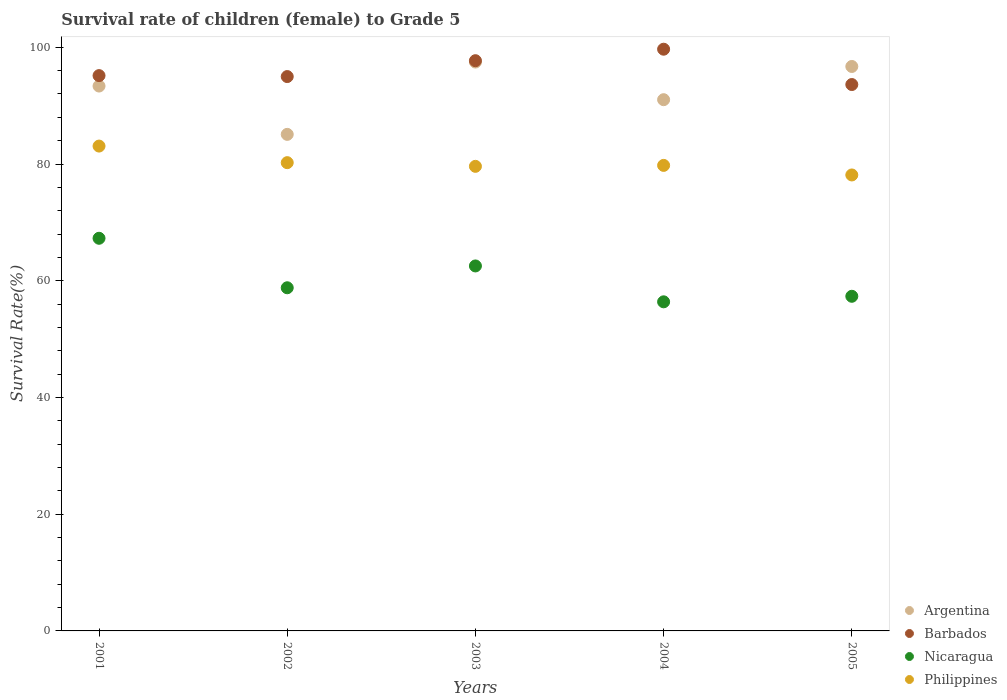How many different coloured dotlines are there?
Your answer should be compact. 4. Is the number of dotlines equal to the number of legend labels?
Keep it short and to the point. Yes. What is the survival rate of female children to grade 5 in Philippines in 2001?
Provide a succinct answer. 83.08. Across all years, what is the maximum survival rate of female children to grade 5 in Philippines?
Offer a very short reply. 83.08. Across all years, what is the minimum survival rate of female children to grade 5 in Philippines?
Provide a short and direct response. 78.13. In which year was the survival rate of female children to grade 5 in Nicaragua maximum?
Ensure brevity in your answer.  2001. In which year was the survival rate of female children to grade 5 in Barbados minimum?
Your answer should be very brief. 2005. What is the total survival rate of female children to grade 5 in Nicaragua in the graph?
Offer a terse response. 302.34. What is the difference between the survival rate of female children to grade 5 in Nicaragua in 2001 and that in 2003?
Ensure brevity in your answer.  4.74. What is the difference between the survival rate of female children to grade 5 in Philippines in 2004 and the survival rate of female children to grade 5 in Argentina in 2005?
Ensure brevity in your answer.  -16.95. What is the average survival rate of female children to grade 5 in Argentina per year?
Your answer should be very brief. 92.73. In the year 2005, what is the difference between the survival rate of female children to grade 5 in Philippines and survival rate of female children to grade 5 in Argentina?
Provide a short and direct response. -18.59. In how many years, is the survival rate of female children to grade 5 in Nicaragua greater than 80 %?
Make the answer very short. 0. What is the ratio of the survival rate of female children to grade 5 in Nicaragua in 2001 to that in 2005?
Offer a terse response. 1.17. Is the difference between the survival rate of female children to grade 5 in Philippines in 2001 and 2005 greater than the difference between the survival rate of female children to grade 5 in Argentina in 2001 and 2005?
Your answer should be compact. Yes. What is the difference between the highest and the second highest survival rate of female children to grade 5 in Barbados?
Offer a very short reply. 1.97. What is the difference between the highest and the lowest survival rate of female children to grade 5 in Philippines?
Offer a very short reply. 4.95. Is the survival rate of female children to grade 5 in Philippines strictly greater than the survival rate of female children to grade 5 in Barbados over the years?
Your answer should be compact. No. Is the survival rate of female children to grade 5 in Nicaragua strictly less than the survival rate of female children to grade 5 in Philippines over the years?
Offer a very short reply. Yes. How many years are there in the graph?
Your response must be concise. 5. Does the graph contain grids?
Your answer should be compact. No. Where does the legend appear in the graph?
Give a very brief answer. Bottom right. What is the title of the graph?
Give a very brief answer. Survival rate of children (female) to Grade 5. What is the label or title of the Y-axis?
Give a very brief answer. Survival Rate(%). What is the Survival Rate(%) of Argentina in 2001?
Your answer should be compact. 93.36. What is the Survival Rate(%) of Barbados in 2001?
Your answer should be very brief. 95.15. What is the Survival Rate(%) in Nicaragua in 2001?
Give a very brief answer. 67.28. What is the Survival Rate(%) in Philippines in 2001?
Provide a short and direct response. 83.08. What is the Survival Rate(%) in Argentina in 2002?
Ensure brevity in your answer.  85.08. What is the Survival Rate(%) of Barbados in 2002?
Make the answer very short. 94.99. What is the Survival Rate(%) of Nicaragua in 2002?
Your response must be concise. 58.8. What is the Survival Rate(%) of Philippines in 2002?
Provide a succinct answer. 80.23. What is the Survival Rate(%) in Argentina in 2003?
Provide a short and direct response. 97.47. What is the Survival Rate(%) in Barbados in 2003?
Keep it short and to the point. 97.71. What is the Survival Rate(%) of Nicaragua in 2003?
Your response must be concise. 62.54. What is the Survival Rate(%) of Philippines in 2003?
Give a very brief answer. 79.6. What is the Survival Rate(%) in Argentina in 2004?
Your response must be concise. 91.02. What is the Survival Rate(%) of Barbados in 2004?
Provide a succinct answer. 99.67. What is the Survival Rate(%) in Nicaragua in 2004?
Provide a short and direct response. 56.39. What is the Survival Rate(%) in Philippines in 2004?
Keep it short and to the point. 79.77. What is the Survival Rate(%) of Argentina in 2005?
Make the answer very short. 96.71. What is the Survival Rate(%) in Barbados in 2005?
Keep it short and to the point. 93.62. What is the Survival Rate(%) of Nicaragua in 2005?
Your answer should be very brief. 57.34. What is the Survival Rate(%) in Philippines in 2005?
Offer a very short reply. 78.13. Across all years, what is the maximum Survival Rate(%) in Argentina?
Provide a short and direct response. 97.47. Across all years, what is the maximum Survival Rate(%) in Barbados?
Your response must be concise. 99.67. Across all years, what is the maximum Survival Rate(%) of Nicaragua?
Provide a short and direct response. 67.28. Across all years, what is the maximum Survival Rate(%) of Philippines?
Provide a succinct answer. 83.08. Across all years, what is the minimum Survival Rate(%) in Argentina?
Offer a very short reply. 85.08. Across all years, what is the minimum Survival Rate(%) in Barbados?
Offer a terse response. 93.62. Across all years, what is the minimum Survival Rate(%) of Nicaragua?
Your answer should be compact. 56.39. Across all years, what is the minimum Survival Rate(%) of Philippines?
Provide a short and direct response. 78.13. What is the total Survival Rate(%) of Argentina in the graph?
Your answer should be very brief. 463.65. What is the total Survival Rate(%) in Barbados in the graph?
Your response must be concise. 481.13. What is the total Survival Rate(%) of Nicaragua in the graph?
Offer a terse response. 302.34. What is the total Survival Rate(%) of Philippines in the graph?
Provide a succinct answer. 400.8. What is the difference between the Survival Rate(%) of Argentina in 2001 and that in 2002?
Give a very brief answer. 8.28. What is the difference between the Survival Rate(%) of Barbados in 2001 and that in 2002?
Make the answer very short. 0.16. What is the difference between the Survival Rate(%) of Nicaragua in 2001 and that in 2002?
Make the answer very short. 8.48. What is the difference between the Survival Rate(%) of Philippines in 2001 and that in 2002?
Provide a succinct answer. 2.84. What is the difference between the Survival Rate(%) of Argentina in 2001 and that in 2003?
Your answer should be compact. -4.11. What is the difference between the Survival Rate(%) of Barbados in 2001 and that in 2003?
Keep it short and to the point. -2.56. What is the difference between the Survival Rate(%) in Nicaragua in 2001 and that in 2003?
Provide a short and direct response. 4.74. What is the difference between the Survival Rate(%) in Philippines in 2001 and that in 2003?
Provide a succinct answer. 3.47. What is the difference between the Survival Rate(%) in Argentina in 2001 and that in 2004?
Give a very brief answer. 2.34. What is the difference between the Survival Rate(%) of Barbados in 2001 and that in 2004?
Your response must be concise. -4.52. What is the difference between the Survival Rate(%) of Nicaragua in 2001 and that in 2004?
Keep it short and to the point. 10.89. What is the difference between the Survival Rate(%) in Philippines in 2001 and that in 2004?
Offer a very short reply. 3.31. What is the difference between the Survival Rate(%) of Argentina in 2001 and that in 2005?
Offer a very short reply. -3.35. What is the difference between the Survival Rate(%) in Barbados in 2001 and that in 2005?
Provide a short and direct response. 1.53. What is the difference between the Survival Rate(%) of Nicaragua in 2001 and that in 2005?
Your answer should be compact. 9.94. What is the difference between the Survival Rate(%) in Philippines in 2001 and that in 2005?
Ensure brevity in your answer.  4.95. What is the difference between the Survival Rate(%) in Argentina in 2002 and that in 2003?
Offer a very short reply. -12.39. What is the difference between the Survival Rate(%) of Barbados in 2002 and that in 2003?
Provide a short and direct response. -2.72. What is the difference between the Survival Rate(%) in Nicaragua in 2002 and that in 2003?
Provide a short and direct response. -3.74. What is the difference between the Survival Rate(%) in Philippines in 2002 and that in 2003?
Offer a very short reply. 0.63. What is the difference between the Survival Rate(%) of Argentina in 2002 and that in 2004?
Your answer should be very brief. -5.94. What is the difference between the Survival Rate(%) in Barbados in 2002 and that in 2004?
Your answer should be compact. -4.69. What is the difference between the Survival Rate(%) in Nicaragua in 2002 and that in 2004?
Offer a terse response. 2.41. What is the difference between the Survival Rate(%) of Philippines in 2002 and that in 2004?
Provide a short and direct response. 0.47. What is the difference between the Survival Rate(%) in Argentina in 2002 and that in 2005?
Keep it short and to the point. -11.63. What is the difference between the Survival Rate(%) in Barbados in 2002 and that in 2005?
Give a very brief answer. 1.37. What is the difference between the Survival Rate(%) of Nicaragua in 2002 and that in 2005?
Provide a succinct answer. 1.46. What is the difference between the Survival Rate(%) in Philippines in 2002 and that in 2005?
Make the answer very short. 2.11. What is the difference between the Survival Rate(%) of Argentina in 2003 and that in 2004?
Offer a terse response. 6.45. What is the difference between the Survival Rate(%) of Barbados in 2003 and that in 2004?
Offer a very short reply. -1.97. What is the difference between the Survival Rate(%) in Nicaragua in 2003 and that in 2004?
Make the answer very short. 6.15. What is the difference between the Survival Rate(%) in Philippines in 2003 and that in 2004?
Your response must be concise. -0.16. What is the difference between the Survival Rate(%) of Argentina in 2003 and that in 2005?
Ensure brevity in your answer.  0.76. What is the difference between the Survival Rate(%) in Barbados in 2003 and that in 2005?
Offer a very short reply. 4.09. What is the difference between the Survival Rate(%) of Philippines in 2003 and that in 2005?
Ensure brevity in your answer.  1.48. What is the difference between the Survival Rate(%) in Argentina in 2004 and that in 2005?
Give a very brief answer. -5.69. What is the difference between the Survival Rate(%) of Barbados in 2004 and that in 2005?
Offer a very short reply. 6.05. What is the difference between the Survival Rate(%) in Nicaragua in 2004 and that in 2005?
Offer a terse response. -0.95. What is the difference between the Survival Rate(%) in Philippines in 2004 and that in 2005?
Offer a very short reply. 1.64. What is the difference between the Survival Rate(%) in Argentina in 2001 and the Survival Rate(%) in Barbados in 2002?
Keep it short and to the point. -1.62. What is the difference between the Survival Rate(%) in Argentina in 2001 and the Survival Rate(%) in Nicaragua in 2002?
Give a very brief answer. 34.56. What is the difference between the Survival Rate(%) of Argentina in 2001 and the Survival Rate(%) of Philippines in 2002?
Give a very brief answer. 13.13. What is the difference between the Survival Rate(%) of Barbados in 2001 and the Survival Rate(%) of Nicaragua in 2002?
Give a very brief answer. 36.35. What is the difference between the Survival Rate(%) in Barbados in 2001 and the Survival Rate(%) in Philippines in 2002?
Your answer should be compact. 14.92. What is the difference between the Survival Rate(%) of Nicaragua in 2001 and the Survival Rate(%) of Philippines in 2002?
Make the answer very short. -12.96. What is the difference between the Survival Rate(%) of Argentina in 2001 and the Survival Rate(%) of Barbados in 2003?
Offer a very short reply. -4.34. What is the difference between the Survival Rate(%) in Argentina in 2001 and the Survival Rate(%) in Nicaragua in 2003?
Ensure brevity in your answer.  30.82. What is the difference between the Survival Rate(%) of Argentina in 2001 and the Survival Rate(%) of Philippines in 2003?
Give a very brief answer. 13.76. What is the difference between the Survival Rate(%) in Barbados in 2001 and the Survival Rate(%) in Nicaragua in 2003?
Offer a terse response. 32.61. What is the difference between the Survival Rate(%) of Barbados in 2001 and the Survival Rate(%) of Philippines in 2003?
Provide a succinct answer. 15.55. What is the difference between the Survival Rate(%) of Nicaragua in 2001 and the Survival Rate(%) of Philippines in 2003?
Your answer should be compact. -12.33. What is the difference between the Survival Rate(%) of Argentina in 2001 and the Survival Rate(%) of Barbados in 2004?
Keep it short and to the point. -6.31. What is the difference between the Survival Rate(%) in Argentina in 2001 and the Survival Rate(%) in Nicaragua in 2004?
Your answer should be compact. 36.97. What is the difference between the Survival Rate(%) in Argentina in 2001 and the Survival Rate(%) in Philippines in 2004?
Offer a very short reply. 13.6. What is the difference between the Survival Rate(%) in Barbados in 2001 and the Survival Rate(%) in Nicaragua in 2004?
Give a very brief answer. 38.76. What is the difference between the Survival Rate(%) of Barbados in 2001 and the Survival Rate(%) of Philippines in 2004?
Keep it short and to the point. 15.38. What is the difference between the Survival Rate(%) of Nicaragua in 2001 and the Survival Rate(%) of Philippines in 2004?
Keep it short and to the point. -12.49. What is the difference between the Survival Rate(%) in Argentina in 2001 and the Survival Rate(%) in Barbados in 2005?
Your answer should be compact. -0.26. What is the difference between the Survival Rate(%) in Argentina in 2001 and the Survival Rate(%) in Nicaragua in 2005?
Your answer should be compact. 36.02. What is the difference between the Survival Rate(%) in Argentina in 2001 and the Survival Rate(%) in Philippines in 2005?
Your answer should be compact. 15.23. What is the difference between the Survival Rate(%) of Barbados in 2001 and the Survival Rate(%) of Nicaragua in 2005?
Your answer should be very brief. 37.81. What is the difference between the Survival Rate(%) of Barbados in 2001 and the Survival Rate(%) of Philippines in 2005?
Give a very brief answer. 17.02. What is the difference between the Survival Rate(%) of Nicaragua in 2001 and the Survival Rate(%) of Philippines in 2005?
Provide a succinct answer. -10.85. What is the difference between the Survival Rate(%) in Argentina in 2002 and the Survival Rate(%) in Barbados in 2003?
Give a very brief answer. -12.62. What is the difference between the Survival Rate(%) in Argentina in 2002 and the Survival Rate(%) in Nicaragua in 2003?
Keep it short and to the point. 22.54. What is the difference between the Survival Rate(%) in Argentina in 2002 and the Survival Rate(%) in Philippines in 2003?
Offer a very short reply. 5.48. What is the difference between the Survival Rate(%) of Barbados in 2002 and the Survival Rate(%) of Nicaragua in 2003?
Offer a very short reply. 32.45. What is the difference between the Survival Rate(%) of Barbados in 2002 and the Survival Rate(%) of Philippines in 2003?
Your answer should be very brief. 15.38. What is the difference between the Survival Rate(%) of Nicaragua in 2002 and the Survival Rate(%) of Philippines in 2003?
Provide a short and direct response. -20.81. What is the difference between the Survival Rate(%) of Argentina in 2002 and the Survival Rate(%) of Barbados in 2004?
Ensure brevity in your answer.  -14.59. What is the difference between the Survival Rate(%) in Argentina in 2002 and the Survival Rate(%) in Nicaragua in 2004?
Your answer should be compact. 28.69. What is the difference between the Survival Rate(%) in Argentina in 2002 and the Survival Rate(%) in Philippines in 2004?
Provide a succinct answer. 5.32. What is the difference between the Survival Rate(%) of Barbados in 2002 and the Survival Rate(%) of Nicaragua in 2004?
Offer a terse response. 38.6. What is the difference between the Survival Rate(%) of Barbados in 2002 and the Survival Rate(%) of Philippines in 2004?
Offer a very short reply. 15.22. What is the difference between the Survival Rate(%) in Nicaragua in 2002 and the Survival Rate(%) in Philippines in 2004?
Your answer should be compact. -20.97. What is the difference between the Survival Rate(%) of Argentina in 2002 and the Survival Rate(%) of Barbados in 2005?
Make the answer very short. -8.54. What is the difference between the Survival Rate(%) in Argentina in 2002 and the Survival Rate(%) in Nicaragua in 2005?
Your response must be concise. 27.74. What is the difference between the Survival Rate(%) in Argentina in 2002 and the Survival Rate(%) in Philippines in 2005?
Provide a succinct answer. 6.95. What is the difference between the Survival Rate(%) of Barbados in 2002 and the Survival Rate(%) of Nicaragua in 2005?
Provide a succinct answer. 37.65. What is the difference between the Survival Rate(%) in Barbados in 2002 and the Survival Rate(%) in Philippines in 2005?
Offer a very short reply. 16.86. What is the difference between the Survival Rate(%) in Nicaragua in 2002 and the Survival Rate(%) in Philippines in 2005?
Your answer should be very brief. -19.33. What is the difference between the Survival Rate(%) in Argentina in 2003 and the Survival Rate(%) in Barbados in 2004?
Make the answer very short. -2.2. What is the difference between the Survival Rate(%) of Argentina in 2003 and the Survival Rate(%) of Nicaragua in 2004?
Your response must be concise. 41.08. What is the difference between the Survival Rate(%) in Argentina in 2003 and the Survival Rate(%) in Philippines in 2004?
Offer a terse response. 17.71. What is the difference between the Survival Rate(%) in Barbados in 2003 and the Survival Rate(%) in Nicaragua in 2004?
Your response must be concise. 41.32. What is the difference between the Survival Rate(%) of Barbados in 2003 and the Survival Rate(%) of Philippines in 2004?
Give a very brief answer. 17.94. What is the difference between the Survival Rate(%) of Nicaragua in 2003 and the Survival Rate(%) of Philippines in 2004?
Your answer should be very brief. -17.23. What is the difference between the Survival Rate(%) of Argentina in 2003 and the Survival Rate(%) of Barbados in 2005?
Make the answer very short. 3.85. What is the difference between the Survival Rate(%) in Argentina in 2003 and the Survival Rate(%) in Nicaragua in 2005?
Offer a terse response. 40.14. What is the difference between the Survival Rate(%) of Argentina in 2003 and the Survival Rate(%) of Philippines in 2005?
Provide a short and direct response. 19.35. What is the difference between the Survival Rate(%) in Barbados in 2003 and the Survival Rate(%) in Nicaragua in 2005?
Give a very brief answer. 40.37. What is the difference between the Survival Rate(%) of Barbados in 2003 and the Survival Rate(%) of Philippines in 2005?
Your response must be concise. 19.58. What is the difference between the Survival Rate(%) of Nicaragua in 2003 and the Survival Rate(%) of Philippines in 2005?
Give a very brief answer. -15.59. What is the difference between the Survival Rate(%) in Argentina in 2004 and the Survival Rate(%) in Barbados in 2005?
Your answer should be very brief. -2.6. What is the difference between the Survival Rate(%) of Argentina in 2004 and the Survival Rate(%) of Nicaragua in 2005?
Your answer should be compact. 33.69. What is the difference between the Survival Rate(%) of Argentina in 2004 and the Survival Rate(%) of Philippines in 2005?
Offer a very short reply. 12.9. What is the difference between the Survival Rate(%) in Barbados in 2004 and the Survival Rate(%) in Nicaragua in 2005?
Your answer should be compact. 42.34. What is the difference between the Survival Rate(%) of Barbados in 2004 and the Survival Rate(%) of Philippines in 2005?
Keep it short and to the point. 21.55. What is the difference between the Survival Rate(%) in Nicaragua in 2004 and the Survival Rate(%) in Philippines in 2005?
Provide a succinct answer. -21.74. What is the average Survival Rate(%) of Argentina per year?
Ensure brevity in your answer.  92.73. What is the average Survival Rate(%) of Barbados per year?
Make the answer very short. 96.23. What is the average Survival Rate(%) in Nicaragua per year?
Give a very brief answer. 60.47. What is the average Survival Rate(%) of Philippines per year?
Give a very brief answer. 80.16. In the year 2001, what is the difference between the Survival Rate(%) in Argentina and Survival Rate(%) in Barbados?
Keep it short and to the point. -1.79. In the year 2001, what is the difference between the Survival Rate(%) of Argentina and Survival Rate(%) of Nicaragua?
Ensure brevity in your answer.  26.08. In the year 2001, what is the difference between the Survival Rate(%) in Argentina and Survival Rate(%) in Philippines?
Provide a succinct answer. 10.29. In the year 2001, what is the difference between the Survival Rate(%) in Barbados and Survival Rate(%) in Nicaragua?
Provide a succinct answer. 27.87. In the year 2001, what is the difference between the Survival Rate(%) of Barbados and Survival Rate(%) of Philippines?
Provide a succinct answer. 12.07. In the year 2001, what is the difference between the Survival Rate(%) of Nicaragua and Survival Rate(%) of Philippines?
Your answer should be compact. -15.8. In the year 2002, what is the difference between the Survival Rate(%) of Argentina and Survival Rate(%) of Barbados?
Offer a terse response. -9.9. In the year 2002, what is the difference between the Survival Rate(%) in Argentina and Survival Rate(%) in Nicaragua?
Make the answer very short. 26.28. In the year 2002, what is the difference between the Survival Rate(%) in Argentina and Survival Rate(%) in Philippines?
Your answer should be very brief. 4.85. In the year 2002, what is the difference between the Survival Rate(%) of Barbados and Survival Rate(%) of Nicaragua?
Keep it short and to the point. 36.19. In the year 2002, what is the difference between the Survival Rate(%) of Barbados and Survival Rate(%) of Philippines?
Offer a terse response. 14.75. In the year 2002, what is the difference between the Survival Rate(%) of Nicaragua and Survival Rate(%) of Philippines?
Offer a very short reply. -21.44. In the year 2003, what is the difference between the Survival Rate(%) of Argentina and Survival Rate(%) of Barbados?
Provide a succinct answer. -0.23. In the year 2003, what is the difference between the Survival Rate(%) in Argentina and Survival Rate(%) in Nicaragua?
Your answer should be compact. 34.94. In the year 2003, what is the difference between the Survival Rate(%) in Argentina and Survival Rate(%) in Philippines?
Your response must be concise. 17.87. In the year 2003, what is the difference between the Survival Rate(%) in Barbados and Survival Rate(%) in Nicaragua?
Give a very brief answer. 35.17. In the year 2003, what is the difference between the Survival Rate(%) in Barbados and Survival Rate(%) in Philippines?
Your answer should be very brief. 18.1. In the year 2003, what is the difference between the Survival Rate(%) of Nicaragua and Survival Rate(%) of Philippines?
Provide a short and direct response. -17.07. In the year 2004, what is the difference between the Survival Rate(%) of Argentina and Survival Rate(%) of Barbados?
Offer a very short reply. -8.65. In the year 2004, what is the difference between the Survival Rate(%) in Argentina and Survival Rate(%) in Nicaragua?
Your response must be concise. 34.63. In the year 2004, what is the difference between the Survival Rate(%) of Argentina and Survival Rate(%) of Philippines?
Offer a very short reply. 11.26. In the year 2004, what is the difference between the Survival Rate(%) of Barbados and Survival Rate(%) of Nicaragua?
Provide a succinct answer. 43.28. In the year 2004, what is the difference between the Survival Rate(%) in Barbados and Survival Rate(%) in Philippines?
Offer a terse response. 19.91. In the year 2004, what is the difference between the Survival Rate(%) of Nicaragua and Survival Rate(%) of Philippines?
Provide a succinct answer. -23.38. In the year 2005, what is the difference between the Survival Rate(%) in Argentina and Survival Rate(%) in Barbados?
Your answer should be compact. 3.09. In the year 2005, what is the difference between the Survival Rate(%) of Argentina and Survival Rate(%) of Nicaragua?
Provide a succinct answer. 39.38. In the year 2005, what is the difference between the Survival Rate(%) in Argentina and Survival Rate(%) in Philippines?
Make the answer very short. 18.59. In the year 2005, what is the difference between the Survival Rate(%) of Barbados and Survival Rate(%) of Nicaragua?
Ensure brevity in your answer.  36.28. In the year 2005, what is the difference between the Survival Rate(%) of Barbados and Survival Rate(%) of Philippines?
Your response must be concise. 15.49. In the year 2005, what is the difference between the Survival Rate(%) of Nicaragua and Survival Rate(%) of Philippines?
Keep it short and to the point. -20.79. What is the ratio of the Survival Rate(%) in Argentina in 2001 to that in 2002?
Give a very brief answer. 1.1. What is the ratio of the Survival Rate(%) in Nicaragua in 2001 to that in 2002?
Offer a terse response. 1.14. What is the ratio of the Survival Rate(%) of Philippines in 2001 to that in 2002?
Offer a very short reply. 1.04. What is the ratio of the Survival Rate(%) of Argentina in 2001 to that in 2003?
Keep it short and to the point. 0.96. What is the ratio of the Survival Rate(%) of Barbados in 2001 to that in 2003?
Make the answer very short. 0.97. What is the ratio of the Survival Rate(%) in Nicaragua in 2001 to that in 2003?
Your response must be concise. 1.08. What is the ratio of the Survival Rate(%) of Philippines in 2001 to that in 2003?
Keep it short and to the point. 1.04. What is the ratio of the Survival Rate(%) in Argentina in 2001 to that in 2004?
Ensure brevity in your answer.  1.03. What is the ratio of the Survival Rate(%) in Barbados in 2001 to that in 2004?
Keep it short and to the point. 0.95. What is the ratio of the Survival Rate(%) in Nicaragua in 2001 to that in 2004?
Your answer should be compact. 1.19. What is the ratio of the Survival Rate(%) of Philippines in 2001 to that in 2004?
Ensure brevity in your answer.  1.04. What is the ratio of the Survival Rate(%) of Argentina in 2001 to that in 2005?
Your response must be concise. 0.97. What is the ratio of the Survival Rate(%) in Barbados in 2001 to that in 2005?
Your answer should be compact. 1.02. What is the ratio of the Survival Rate(%) in Nicaragua in 2001 to that in 2005?
Give a very brief answer. 1.17. What is the ratio of the Survival Rate(%) in Philippines in 2001 to that in 2005?
Your response must be concise. 1.06. What is the ratio of the Survival Rate(%) in Argentina in 2002 to that in 2003?
Your answer should be very brief. 0.87. What is the ratio of the Survival Rate(%) of Barbados in 2002 to that in 2003?
Your response must be concise. 0.97. What is the ratio of the Survival Rate(%) of Nicaragua in 2002 to that in 2003?
Your answer should be compact. 0.94. What is the ratio of the Survival Rate(%) in Philippines in 2002 to that in 2003?
Make the answer very short. 1.01. What is the ratio of the Survival Rate(%) in Argentina in 2002 to that in 2004?
Offer a terse response. 0.93. What is the ratio of the Survival Rate(%) of Barbados in 2002 to that in 2004?
Ensure brevity in your answer.  0.95. What is the ratio of the Survival Rate(%) in Nicaragua in 2002 to that in 2004?
Give a very brief answer. 1.04. What is the ratio of the Survival Rate(%) of Philippines in 2002 to that in 2004?
Offer a very short reply. 1.01. What is the ratio of the Survival Rate(%) in Argentina in 2002 to that in 2005?
Offer a terse response. 0.88. What is the ratio of the Survival Rate(%) of Barbados in 2002 to that in 2005?
Provide a short and direct response. 1.01. What is the ratio of the Survival Rate(%) in Nicaragua in 2002 to that in 2005?
Your answer should be very brief. 1.03. What is the ratio of the Survival Rate(%) in Argentina in 2003 to that in 2004?
Your answer should be very brief. 1.07. What is the ratio of the Survival Rate(%) in Barbados in 2003 to that in 2004?
Provide a short and direct response. 0.98. What is the ratio of the Survival Rate(%) of Nicaragua in 2003 to that in 2004?
Your answer should be compact. 1.11. What is the ratio of the Survival Rate(%) of Barbados in 2003 to that in 2005?
Give a very brief answer. 1.04. What is the ratio of the Survival Rate(%) of Nicaragua in 2003 to that in 2005?
Ensure brevity in your answer.  1.09. What is the ratio of the Survival Rate(%) in Philippines in 2003 to that in 2005?
Provide a succinct answer. 1.02. What is the ratio of the Survival Rate(%) of Argentina in 2004 to that in 2005?
Offer a terse response. 0.94. What is the ratio of the Survival Rate(%) in Barbados in 2004 to that in 2005?
Offer a very short reply. 1.06. What is the ratio of the Survival Rate(%) of Nicaragua in 2004 to that in 2005?
Offer a very short reply. 0.98. What is the difference between the highest and the second highest Survival Rate(%) of Argentina?
Your response must be concise. 0.76. What is the difference between the highest and the second highest Survival Rate(%) in Barbados?
Give a very brief answer. 1.97. What is the difference between the highest and the second highest Survival Rate(%) in Nicaragua?
Keep it short and to the point. 4.74. What is the difference between the highest and the second highest Survival Rate(%) of Philippines?
Your answer should be compact. 2.84. What is the difference between the highest and the lowest Survival Rate(%) in Argentina?
Offer a very short reply. 12.39. What is the difference between the highest and the lowest Survival Rate(%) in Barbados?
Offer a very short reply. 6.05. What is the difference between the highest and the lowest Survival Rate(%) of Nicaragua?
Ensure brevity in your answer.  10.89. What is the difference between the highest and the lowest Survival Rate(%) of Philippines?
Your answer should be very brief. 4.95. 